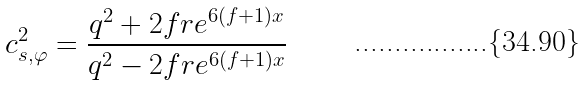Convert formula to latex. <formula><loc_0><loc_0><loc_500><loc_500>c _ { s , \varphi } ^ { 2 } = \frac { q ^ { 2 } + 2 f r e ^ { 6 ( f + 1 ) x } } { q ^ { 2 } - 2 f r e ^ { 6 ( f + 1 ) x } }</formula> 